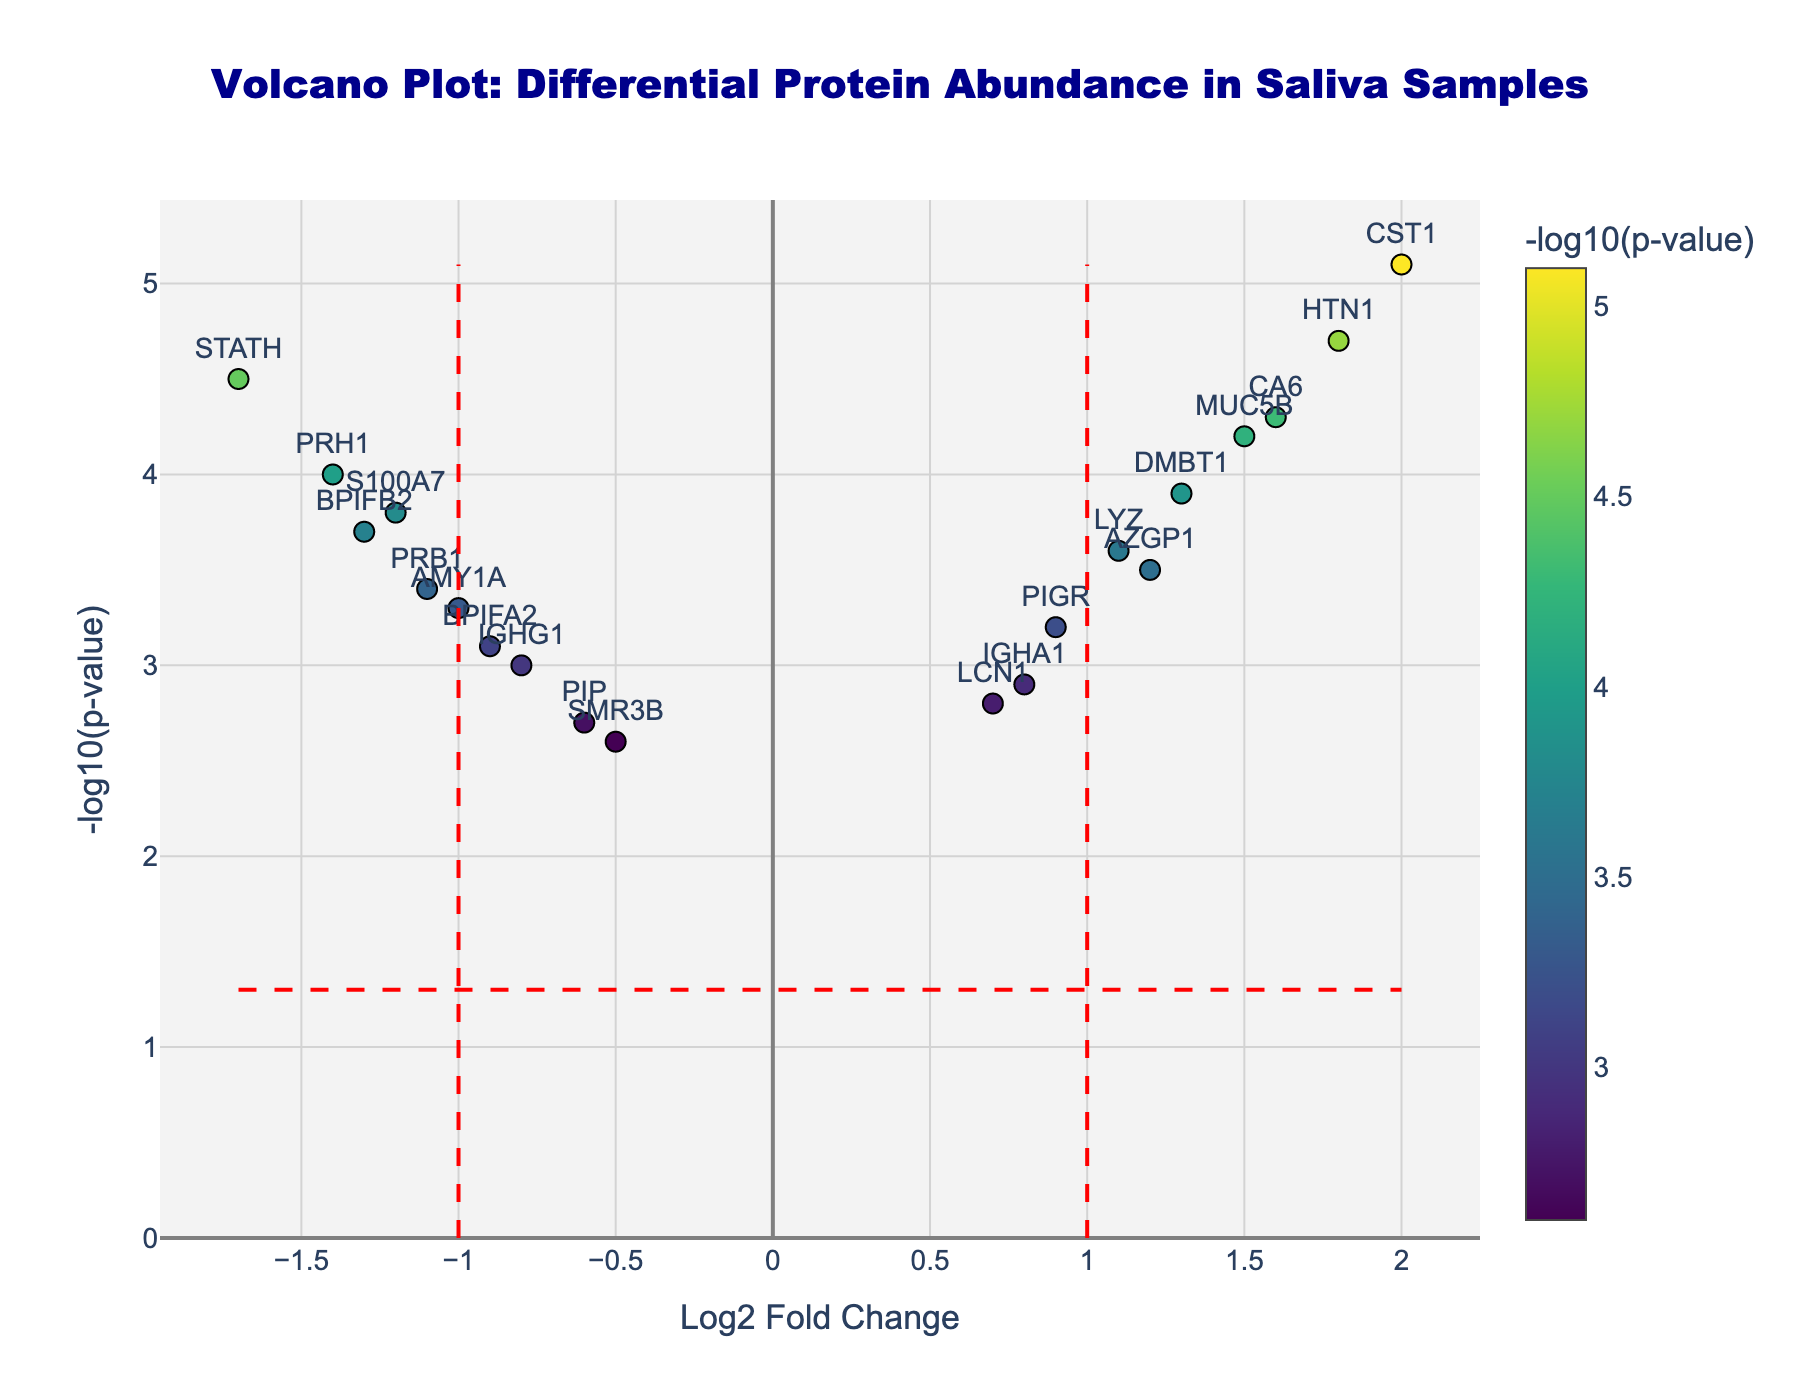What is the title of the figure? The title is found at the top center of the figure and is often written in a larger, bold font.
Answer: Volcano Plot: Differential Protein Abundance in Saliva Samples What are the labels of the x-axis and y-axis? The x-axis label represents the "Log2 Fold Change" and the y-axis label represents the "-log10(p-value)", which are usually found at the bottom of the x-axis and the left of the y-axis.
Answer: Log2 Fold Change, -log10(p-value) How many proteins have a Log2 Fold Change greater than 1? By locating the proteins plotted on the right side of the red threshold line at Log2 Fold Change = 1, we can count that there are 5 such proteins.
Answer: 5 Which protein has the highest -log10(p-value)? The protein with the highest -log10(p-value) can be found by identifying the point plotted at the highest position on the y-axis. This is the protein CST1.
Answer: CST1 What is the Log2 Fold Change and -log10(p-value) of the protein STATH? By looking at the data point labeled "STATH", its coordinates can be read as Log2 Fold Change = -1.7 and -log10(p-value) = 4.5.
Answer: Log2 Fold Change = -1.7, -log10(p-value) = 4.5 Which proteins have been highlighted to pass the p-value threshold line? The proteins above the red dashed horizontal line (neg_log10_pvalue_threshold = ~1.3) are highlighted, these include: S100A7, IGHA1, MUC5B, BPIFA2, LYZ, STATH, CST1, DMBT1, AMY1A, PRH1, HTN1, AZGP1, PRB1, PIGR, BPIFB2, CA6 and IGHG1.
Answer: S100A7, IGHA1, MUC5B, BPIFA2, LYZ, STATH, CST1, DMBT1, AMY1A, PRH1, HTN1, AZGP1, PRB1, PIGR, BPIFB2, CA6, IGHG1 Which protein is closest to the origin (0,0)? By identifying the protein plotted closest to the intersection of x-axis and y-axis (0, 0), we find this is SMR3B.
Answer: SMR3B Among the proteins PIP and IGHA1, which one has the higher Log2 Fold Change? By comparing the Log2 Fold Change values of PIP and IGHA1 from their positions along the x-axis, IGHA1 has a higher Log2 Fold Change (0.8) than PIP (-0.6).
Answer: IGHA1 What is the Log2 Fold Change difference between CA6 and AMY1A? The Log2 Fold Change of CA6 is 1.6 and for AMY1A it is -1.0. The difference is calculated as 1.6 - (-1.0) = 1.6 + 1 = 2.6.
Answer: 2.6 